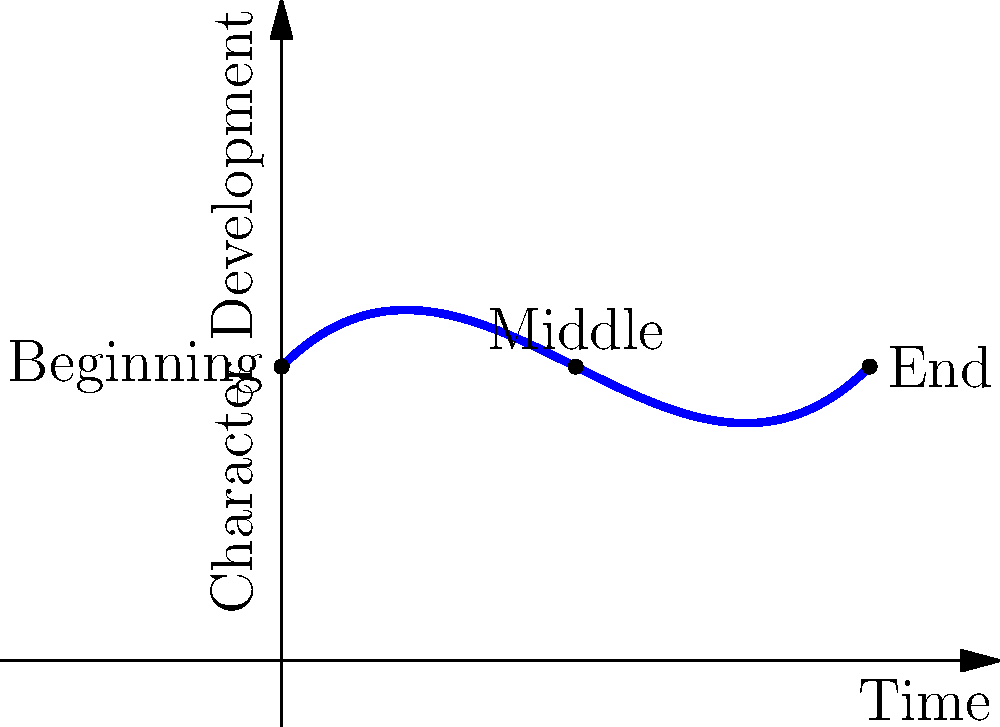In the character arc visualization above, which part of the story represents the most significant growth or change for the protagonist? To determine where the most significant growth or change occurs in the character arc, we need to analyze the curve:

1. The graph represents the character's development over time, with the x-axis showing the progression of the story and the y-axis indicating the level of character development.

2. The curve starts at the "Beginning" point, rises through the "Middle," and ends at the "End" point.

3. To find the area of most significant growth, we need to identify the steepest part of the curve, which represents the fastest rate of change.

4. Observing the graph, we can see that the steepest section of the curve occurs between the "Middle" and "End" points.

5. This steep incline indicates that the character undergoes the most substantial development or change in the latter half of the story.

6. The first half of the story (from "Beginning" to "Middle") shows a more gradual change, suggesting slower character development.

Therefore, the most significant growth or change for the protagonist occurs in the second half of the story, between the "Middle" and "End" points.
Answer: Second half (between Middle and End) 